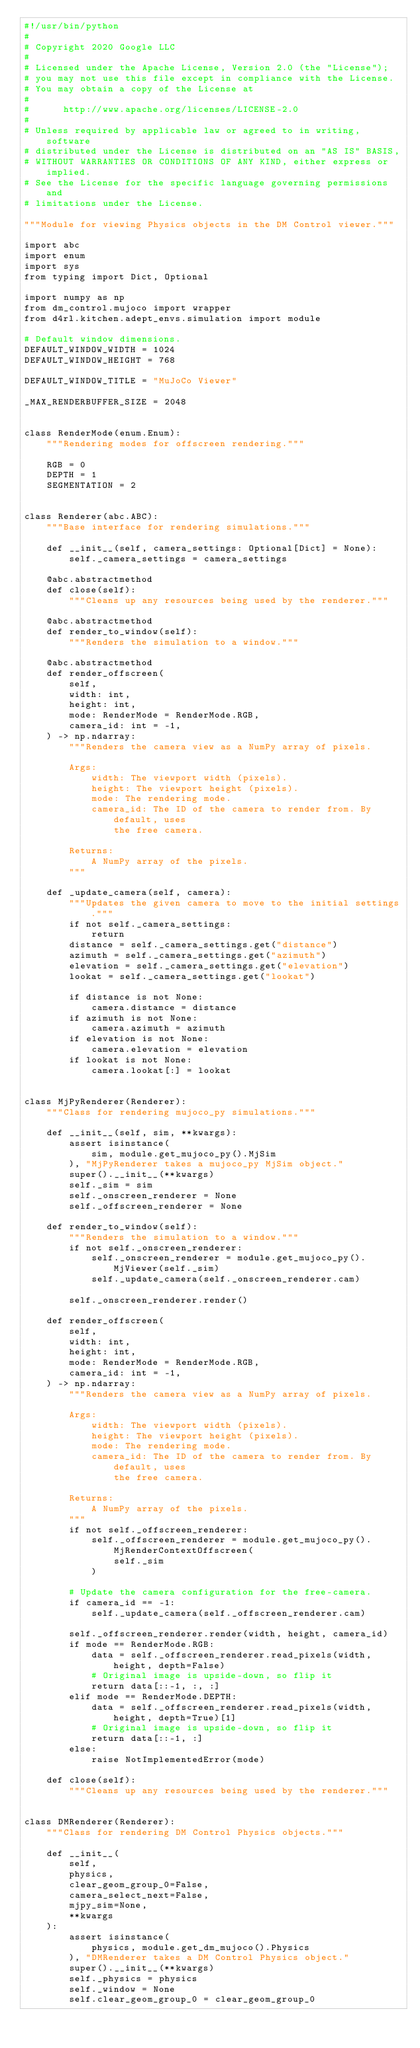<code> <loc_0><loc_0><loc_500><loc_500><_Python_>#!/usr/bin/python
#
# Copyright 2020 Google LLC
#
# Licensed under the Apache License, Version 2.0 (the "License");
# you may not use this file except in compliance with the License.
# You may obtain a copy of the License at
#
#      http://www.apache.org/licenses/LICENSE-2.0
#
# Unless required by applicable law or agreed to in writing, software
# distributed under the License is distributed on an "AS IS" BASIS,
# WITHOUT WARRANTIES OR CONDITIONS OF ANY KIND, either express or implied.
# See the License for the specific language governing permissions and
# limitations under the License.

"""Module for viewing Physics objects in the DM Control viewer."""

import abc
import enum
import sys
from typing import Dict, Optional

import numpy as np
from dm_control.mujoco import wrapper
from d4rl.kitchen.adept_envs.simulation import module

# Default window dimensions.
DEFAULT_WINDOW_WIDTH = 1024
DEFAULT_WINDOW_HEIGHT = 768

DEFAULT_WINDOW_TITLE = "MuJoCo Viewer"

_MAX_RENDERBUFFER_SIZE = 2048


class RenderMode(enum.Enum):
    """Rendering modes for offscreen rendering."""

    RGB = 0
    DEPTH = 1
    SEGMENTATION = 2


class Renderer(abc.ABC):
    """Base interface for rendering simulations."""

    def __init__(self, camera_settings: Optional[Dict] = None):
        self._camera_settings = camera_settings

    @abc.abstractmethod
    def close(self):
        """Cleans up any resources being used by the renderer."""

    @abc.abstractmethod
    def render_to_window(self):
        """Renders the simulation to a window."""

    @abc.abstractmethod
    def render_offscreen(
        self,
        width: int,
        height: int,
        mode: RenderMode = RenderMode.RGB,
        camera_id: int = -1,
    ) -> np.ndarray:
        """Renders the camera view as a NumPy array of pixels.

        Args:
            width: The viewport width (pixels).
            height: The viewport height (pixels).
            mode: The rendering mode.
            camera_id: The ID of the camera to render from. By default, uses
                the free camera.

        Returns:
            A NumPy array of the pixels.
        """

    def _update_camera(self, camera):
        """Updates the given camera to move to the initial settings."""
        if not self._camera_settings:
            return
        distance = self._camera_settings.get("distance")
        azimuth = self._camera_settings.get("azimuth")
        elevation = self._camera_settings.get("elevation")
        lookat = self._camera_settings.get("lookat")

        if distance is not None:
            camera.distance = distance
        if azimuth is not None:
            camera.azimuth = azimuth
        if elevation is not None:
            camera.elevation = elevation
        if lookat is not None:
            camera.lookat[:] = lookat


class MjPyRenderer(Renderer):
    """Class for rendering mujoco_py simulations."""

    def __init__(self, sim, **kwargs):
        assert isinstance(
            sim, module.get_mujoco_py().MjSim
        ), "MjPyRenderer takes a mujoco_py MjSim object."
        super().__init__(**kwargs)
        self._sim = sim
        self._onscreen_renderer = None
        self._offscreen_renderer = None

    def render_to_window(self):
        """Renders the simulation to a window."""
        if not self._onscreen_renderer:
            self._onscreen_renderer = module.get_mujoco_py().MjViewer(self._sim)
            self._update_camera(self._onscreen_renderer.cam)

        self._onscreen_renderer.render()

    def render_offscreen(
        self,
        width: int,
        height: int,
        mode: RenderMode = RenderMode.RGB,
        camera_id: int = -1,
    ) -> np.ndarray:
        """Renders the camera view as a NumPy array of pixels.

        Args:
            width: The viewport width (pixels).
            height: The viewport height (pixels).
            mode: The rendering mode.
            camera_id: The ID of the camera to render from. By default, uses
                the free camera.

        Returns:
            A NumPy array of the pixels.
        """
        if not self._offscreen_renderer:
            self._offscreen_renderer = module.get_mujoco_py().MjRenderContextOffscreen(
                self._sim
            )

        # Update the camera configuration for the free-camera.
        if camera_id == -1:
            self._update_camera(self._offscreen_renderer.cam)

        self._offscreen_renderer.render(width, height, camera_id)
        if mode == RenderMode.RGB:
            data = self._offscreen_renderer.read_pixels(width, height, depth=False)
            # Original image is upside-down, so flip it
            return data[::-1, :, :]
        elif mode == RenderMode.DEPTH:
            data = self._offscreen_renderer.read_pixels(width, height, depth=True)[1]
            # Original image is upside-down, so flip it
            return data[::-1, :]
        else:
            raise NotImplementedError(mode)

    def close(self):
        """Cleans up any resources being used by the renderer."""


class DMRenderer(Renderer):
    """Class for rendering DM Control Physics objects."""

    def __init__(
        self,
        physics,
        clear_geom_group_0=False,
        camera_select_next=False,
        mjpy_sim=None,
        **kwargs
    ):
        assert isinstance(
            physics, module.get_dm_mujoco().Physics
        ), "DMRenderer takes a DM Control Physics object."
        super().__init__(**kwargs)
        self._physics = physics
        self._window = None
        self.clear_geom_group_0 = clear_geom_group_0</code> 